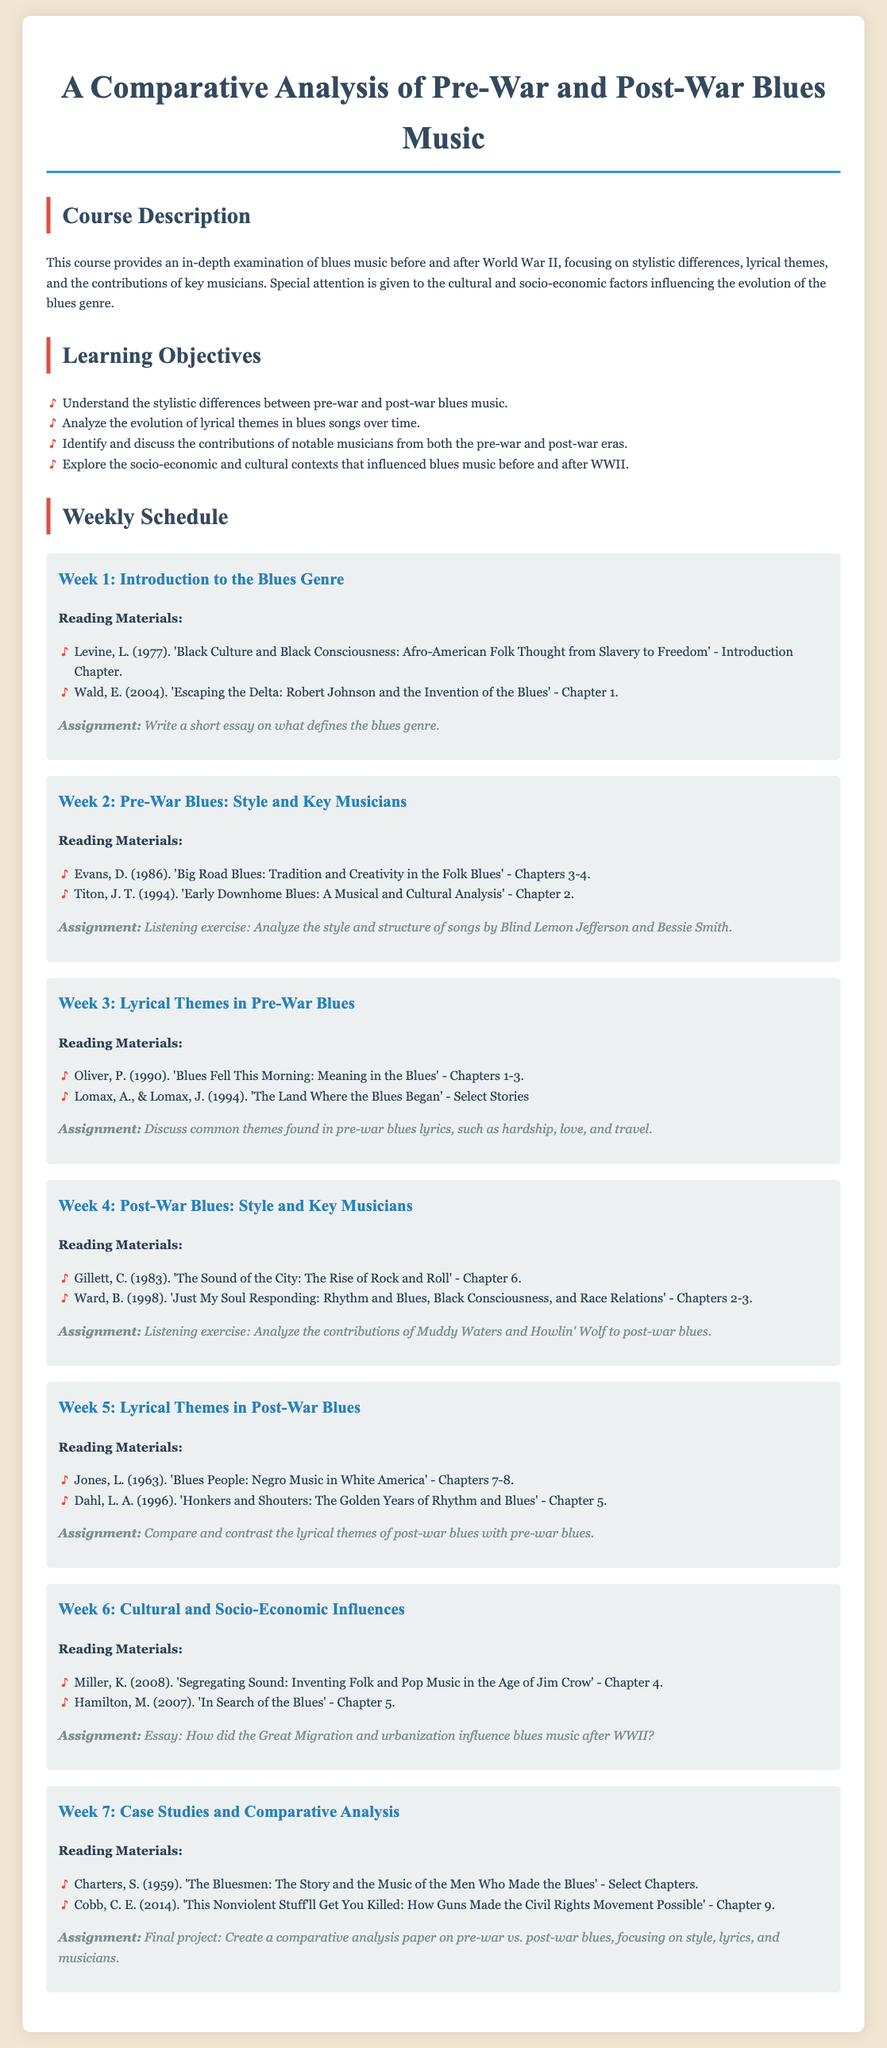What is the title of the course? The title of the course is specified at the top of the document, which is "A Comparative Analysis of Pre-War and Post-War Blues Music."
Answer: A Comparative Analysis of Pre-War and Post-War Blues Music What is the focus of the course? The focus of the course is mentioned in the course description, emphasizing stylistic differences, lyrical themes, and contributions of key musicians in blues music.
Answer: Stylistic differences, lyrical themes, and contributions of key musicians How many weeks are covered in the syllabus? The weekly schedule outlines activities for a total of seven weeks.
Answer: 7 Which reading material is assigned for Week 2? The reading materials for Week 2 are specified in the weekly schedule, focusing on pre-war blues style and key musicians.
Answer: 'Big Road Blues: Tradition and Creativity in the Folk Blues' - Chapters 3-4 and 'Early Downhome Blues: A Musical and Cultural Analysis' - Chapter 2 What is expected in the final project? The assignment for the final project requires creating a comparative analysis paper on pre-war and post-war blues.
Answer: Comparative analysis paper on pre-war vs. post-war blues What thematic elements are discussed in Week 3's assignments? The assignments in Week 3 focus on discussing common themes found in pre-war blues lyrics, encompassing various aspects of life.
Answer: Hardship, love, and travel Which musician is highlighted for Week 4's listening exercise? The listening exercise in Week 4 highlights contributions from specific musicians in post-war blues, notably Muddy Waters and Howlin' Wolf.
Answer: Muddy Waters and Howlin' Wolf What socio-economic influence is examined in Week 6's essay assignment? The essay assignment in Week 6 asks about the influence of historical events on blues music following WWII, specifically the Great Migration and urbanization.
Answer: Great Migration and urbanization 